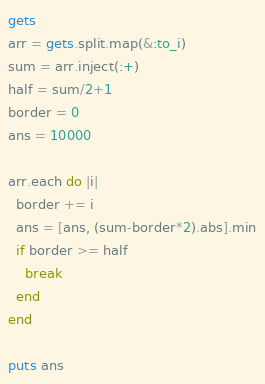<code> <loc_0><loc_0><loc_500><loc_500><_Ruby_>gets
arr = gets.split.map(&:to_i)
sum = arr.inject(:+)
half = sum/2+1
border = 0
ans = 10000

arr.each do |i|
  border += i
  ans = [ans, (sum-border*2).abs].min
  if border >= half
    break
  end
end

puts ans</code> 